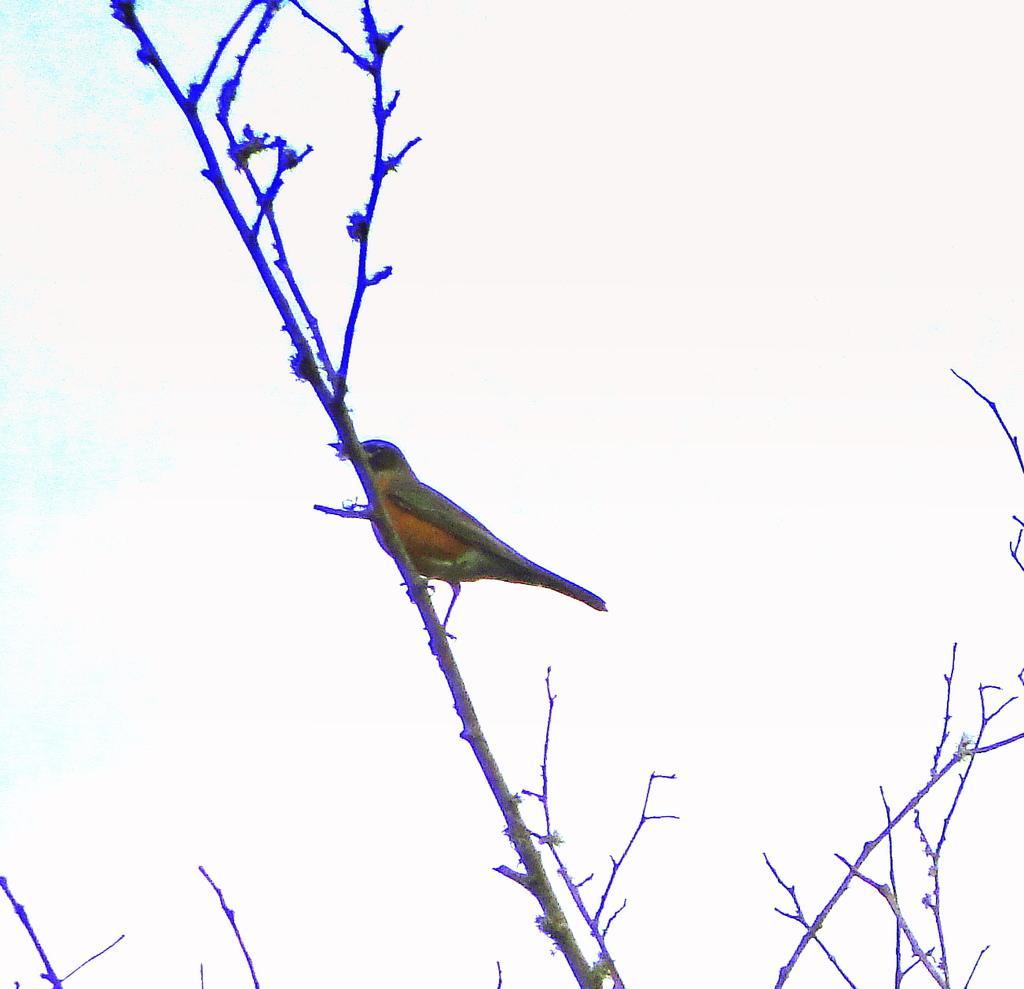How would you summarize this image in a sentence or two? It seems like an edited image, there is a bird sitting on the branch of a tree. 